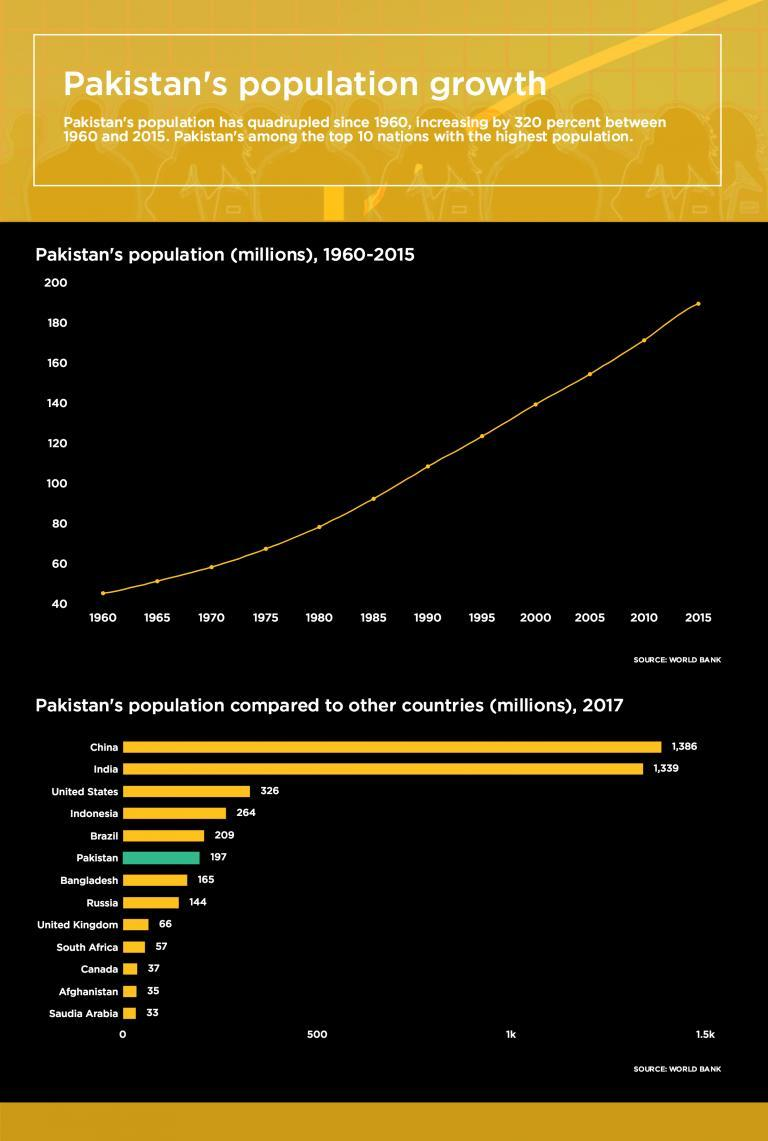How many countries have less than 500 million population?
Answer the question with a short phrase. 11 Which all countries have less than 50 million population? Canada, Afghanistan, Saudia Arabia How many countries have less than 50 million population? 3 